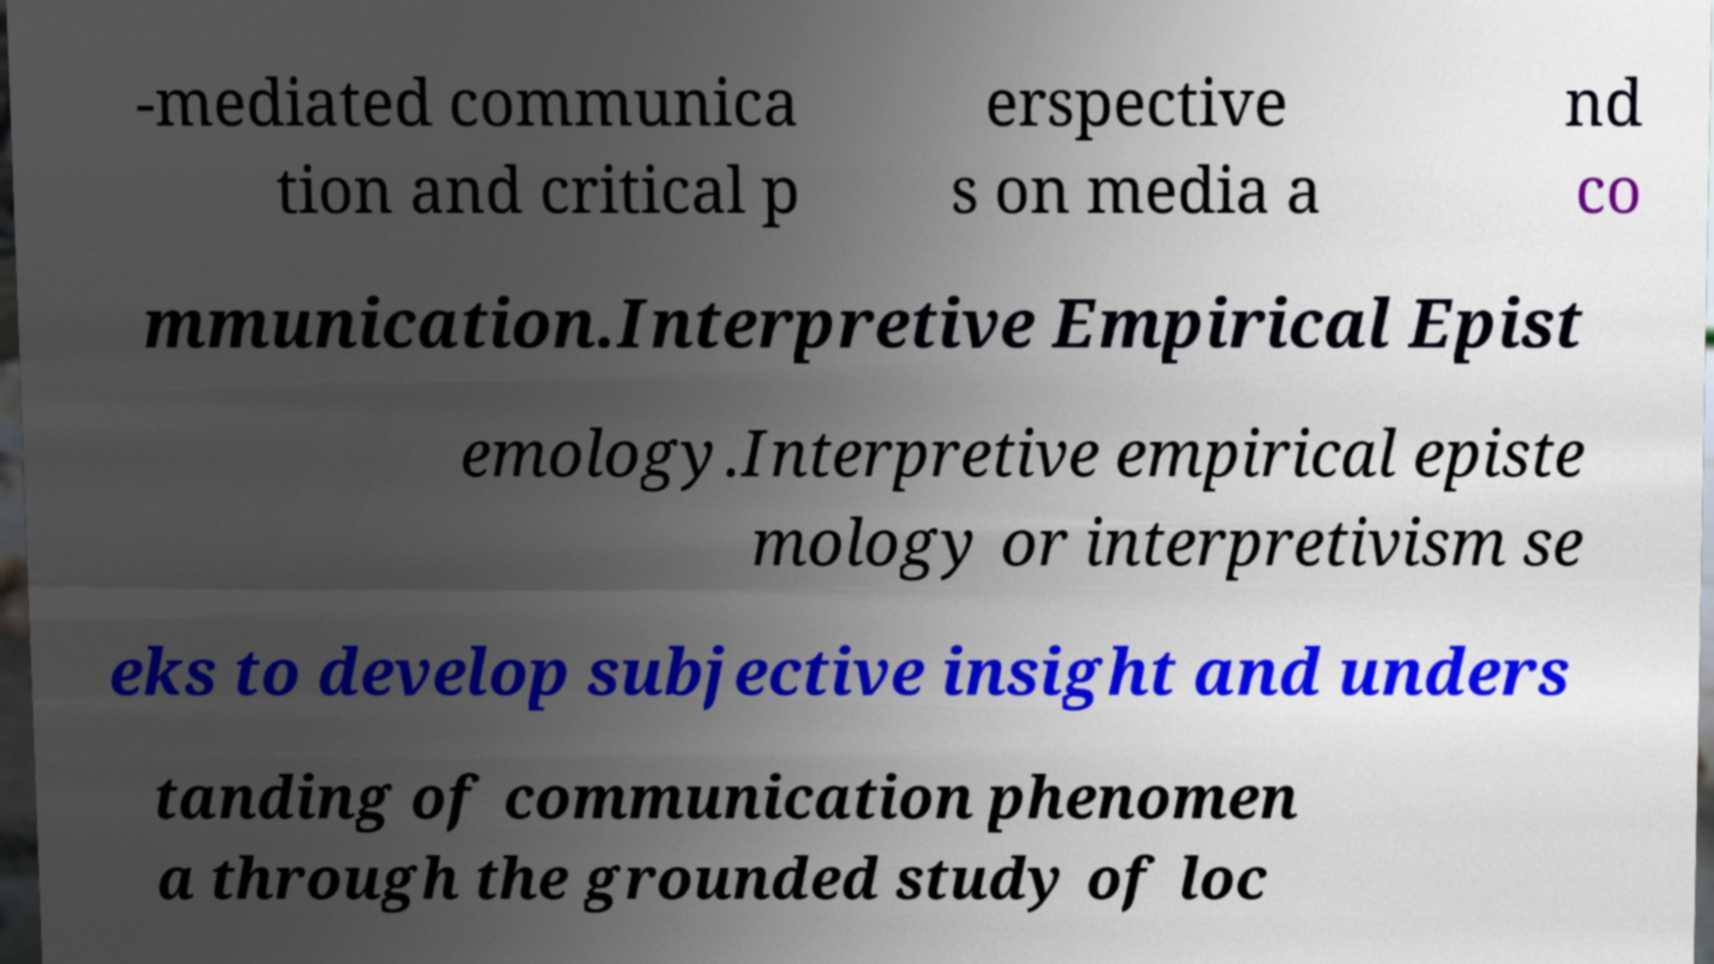There's text embedded in this image that I need extracted. Can you transcribe it verbatim? -mediated communica tion and critical p erspective s on media a nd co mmunication.Interpretive Empirical Epist emology.Interpretive empirical episte mology or interpretivism se eks to develop subjective insight and unders tanding of communication phenomen a through the grounded study of loc 